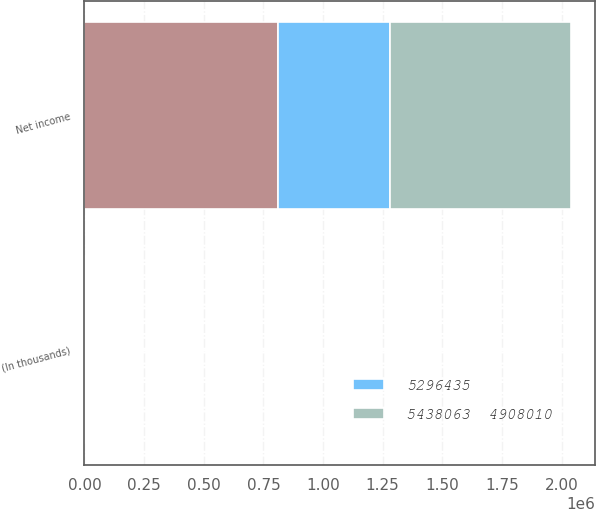<chart> <loc_0><loc_0><loc_500><loc_500><stacked_bar_chart><ecel><fcel>(In thousands)<fcel>Net income<nl><fcel>nan<fcel>2015<fcel>813303<nl><fcel>5438063  4908010<fcel>2014<fcel>757010<nl><fcel>5296435<fcel>2013<fcel>468850<nl></chart> 